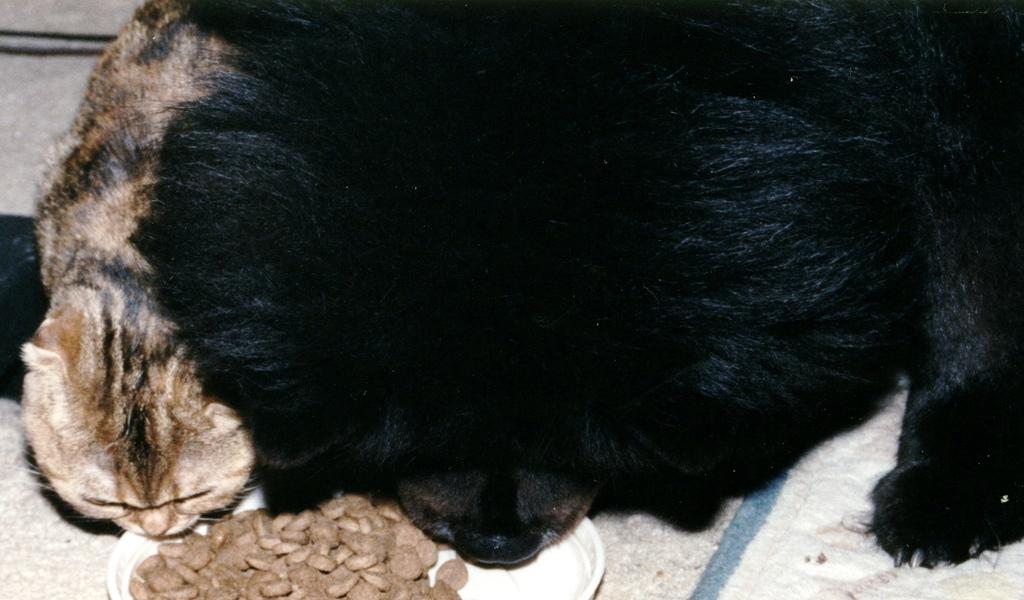What animals are present in the image? There is a dog and a cat in the image. Where are the dog and cat located in the image? Both the dog and cat are sitting on the floor. What is on the floor that the dog and cat are sitting on? There is a mat on the floor in the image. What can be seen on the plate in the image? There is food on a plate in the image. What type of spark can be seen coming from the cat's tail in the image? There is no spark present in the image; both the dog and cat are sitting calmly on the floor. 